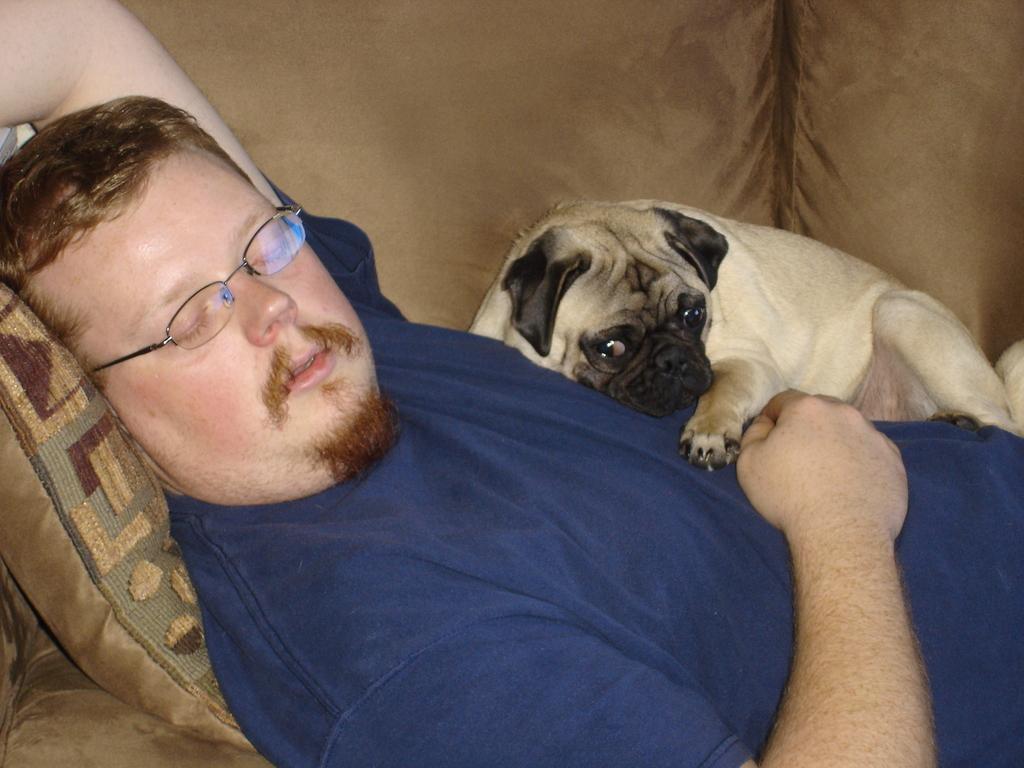How would you summarize this image in a sentence or two? A person wearing a blue t shirt and a spectacles is sleeping. A pillow is there. A dog is lying over him. 